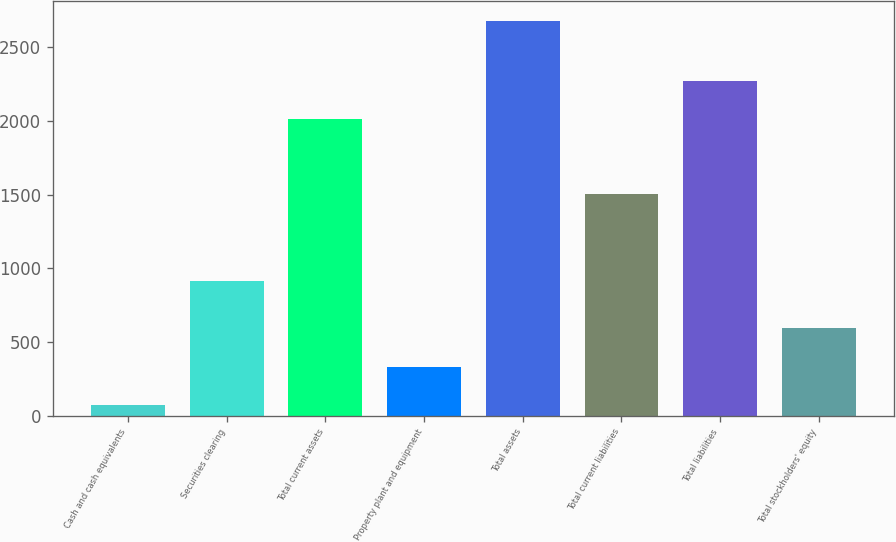Convert chart to OTSL. <chart><loc_0><loc_0><loc_500><loc_500><bar_chart><fcel>Cash and cash equivalents<fcel>Securities clearing<fcel>Total current assets<fcel>Property plant and equipment<fcel>Total assets<fcel>Total current liabilities<fcel>Total liabilities<fcel>Total stockholders' equity<nl><fcel>72.2<fcel>915.4<fcel>2013.7<fcel>332.8<fcel>2678.2<fcel>1501.8<fcel>2274.3<fcel>593.4<nl></chart> 